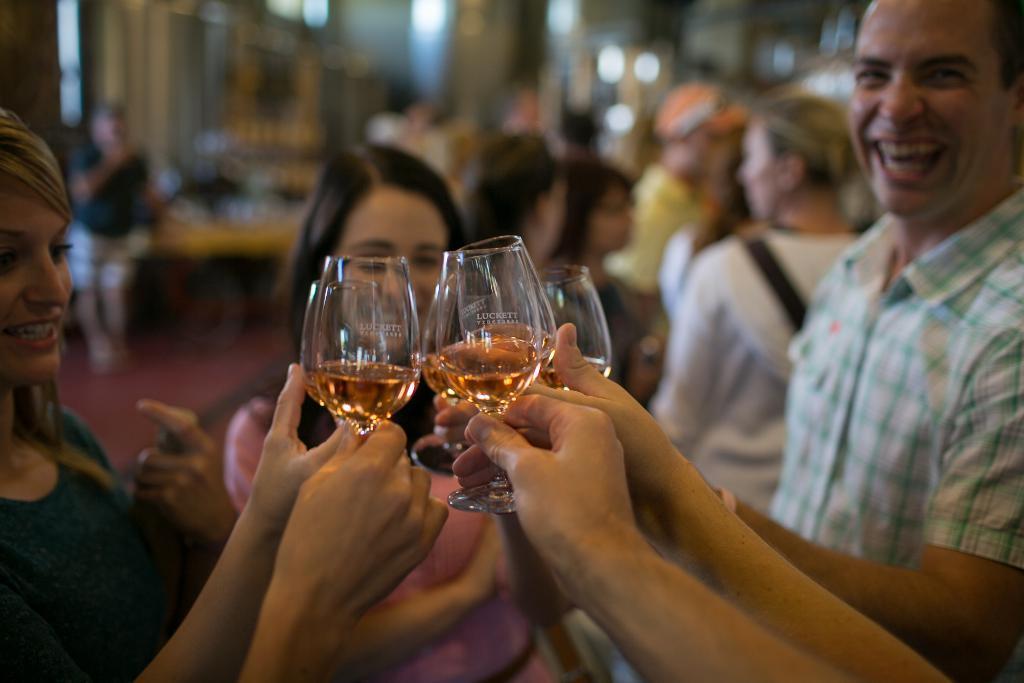How would you summarize this image in a sentence or two? In this picture there are group of people. In the front there are people holding glasses in their hand and smiling. There is drink in the glass and on the glass there is a text. In the background there are people and its blurred.  